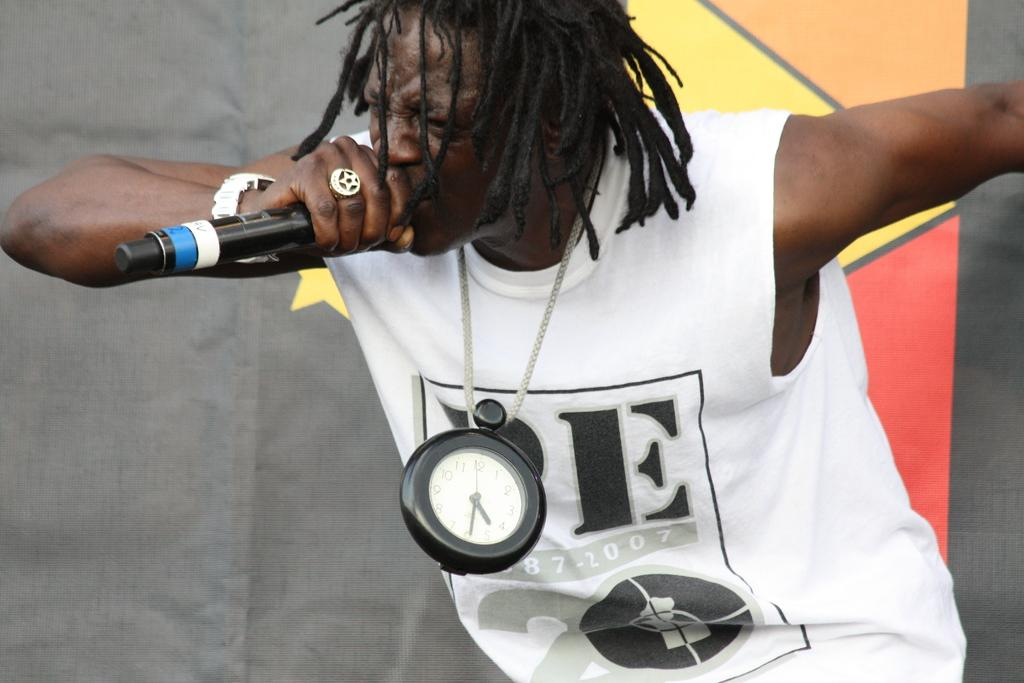<image>
Give a short and clear explanation of the subsequent image. the tshirt that the man is wearing has a letter E on it 